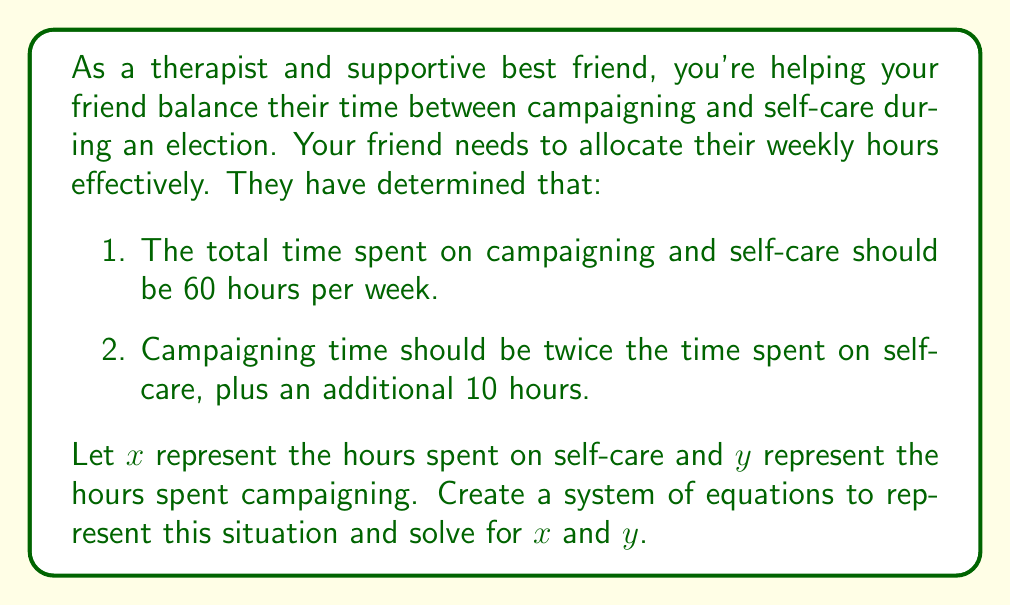Could you help me with this problem? Let's approach this step-by-step:

1. First, let's define our variables:
   $x$ = hours spent on self-care
   $y$ = hours spent campaigning

2. Now, let's create our system of equations based on the given information:

   Equation 1: Total time constraint
   $$x + y = 60$$

   Equation 2: Relationship between campaigning and self-care time
   $$y = 2x + 10$$

3. We now have a system of two equations with two unknowns:
   $$\begin{cases}
   x + y = 60 \\
   y = 2x + 10
   \end{cases}$$

4. Let's solve this system by substitution. We'll substitute the expression for $y$ from the second equation into the first:

   $$x + (2x + 10) = 60$$

5. Simplify:
   $$x + 2x + 10 = 60$$
   $$3x + 10 = 60$$

6. Subtract 10 from both sides:
   $$3x = 50$$

7. Divide both sides by 3:
   $$x = \frac{50}{3} \approx 16.67$$

8. Now that we know $x$, we can find $y$ by substituting this value into either of our original equations. Let's use the second equation:

   $$y = 2x + 10$$
   $$y = 2(\frac{50}{3}) + 10$$
   $$y = \frac{100}{3} + 10 = \frac{100}{3} + \frac{30}{3} = \frac{130}{3} \approx 43.33$$

9. Therefore, the solution to our system of equations is:
   $$x = \frac{50}{3} \approx 16.67$$
   $$y = \frac{130}{3} \approx 43.33$$
Answer: The solution to the system of equations is:
Self-care time (x): $\frac{50}{3}$ hours (approximately 16.67 hours)
Campaigning time (y): $\frac{130}{3}$ hours (approximately 43.33 hours) 